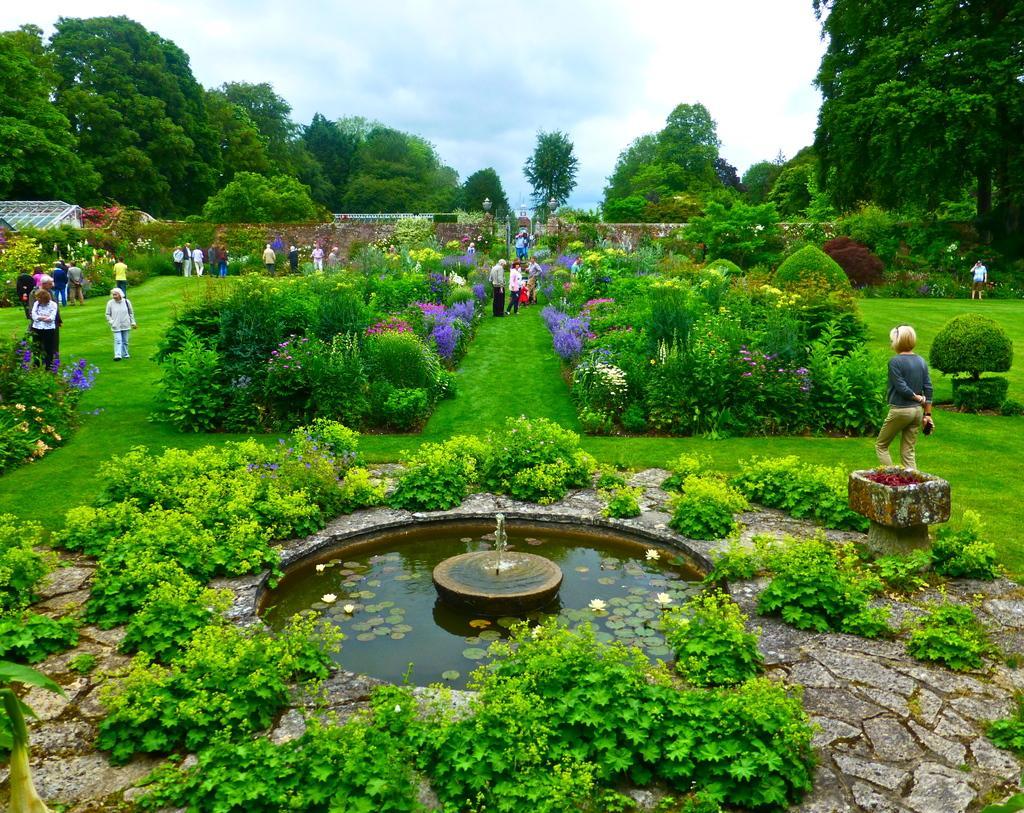In one or two sentences, can you explain what this image depicts? In this image there is a view of a garden, there is the sky towards the top of the image, there are trees, there is grass, there are group of persons, there are plants, there are flowers, there is water, there are leaves and flowers in the water. 